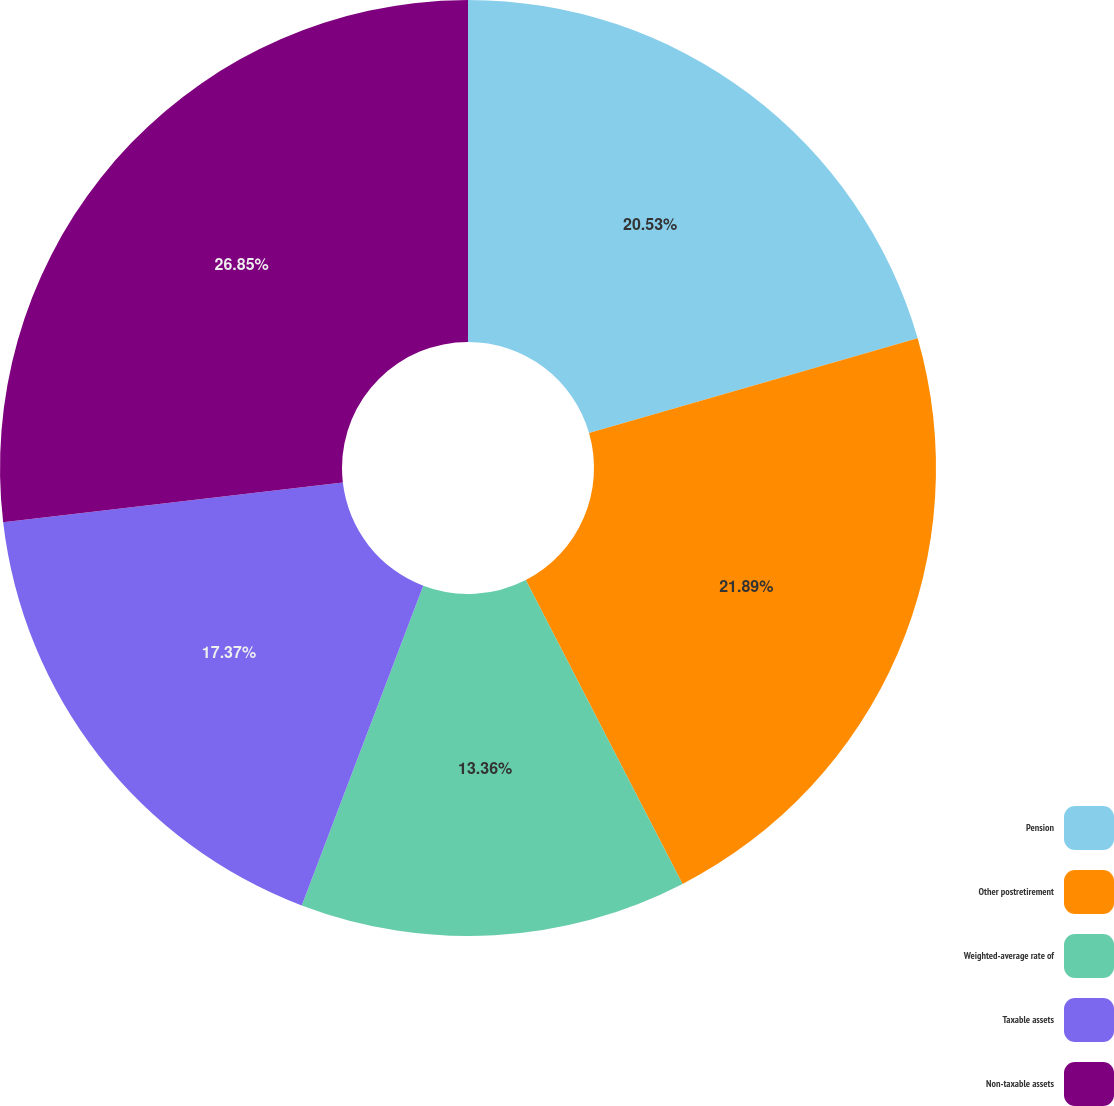<chart> <loc_0><loc_0><loc_500><loc_500><pie_chart><fcel>Pension<fcel>Other postretirement<fcel>Weighted-average rate of<fcel>Taxable assets<fcel>Non-taxable assets<nl><fcel>20.53%<fcel>21.89%<fcel>13.36%<fcel>17.37%<fcel>26.85%<nl></chart> 